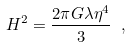<formula> <loc_0><loc_0><loc_500><loc_500>H ^ { 2 } = \frac { 2 \pi G \lambda \eta ^ { 4 } } { 3 } \ ,</formula> 